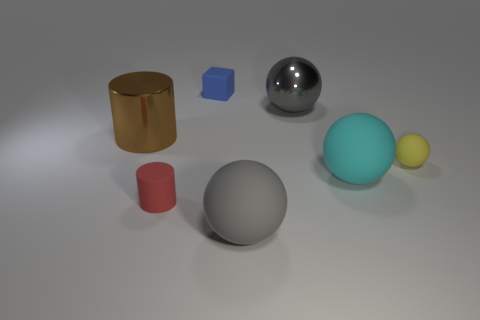Subtract all cyan spheres. How many spheres are left? 3 Subtract all big gray metal balls. How many balls are left? 3 Subtract all brown balls. Subtract all blue blocks. How many balls are left? 4 Add 1 big purple metal blocks. How many objects exist? 8 Subtract all cubes. How many objects are left? 6 Subtract 3 balls. How many balls are left? 1 Subtract all blue balls. How many red cylinders are left? 1 Subtract all large purple shiny cylinders. Subtract all big cyan balls. How many objects are left? 6 Add 3 big cyan rubber spheres. How many big cyan rubber spheres are left? 4 Add 6 small yellow matte things. How many small yellow matte things exist? 7 